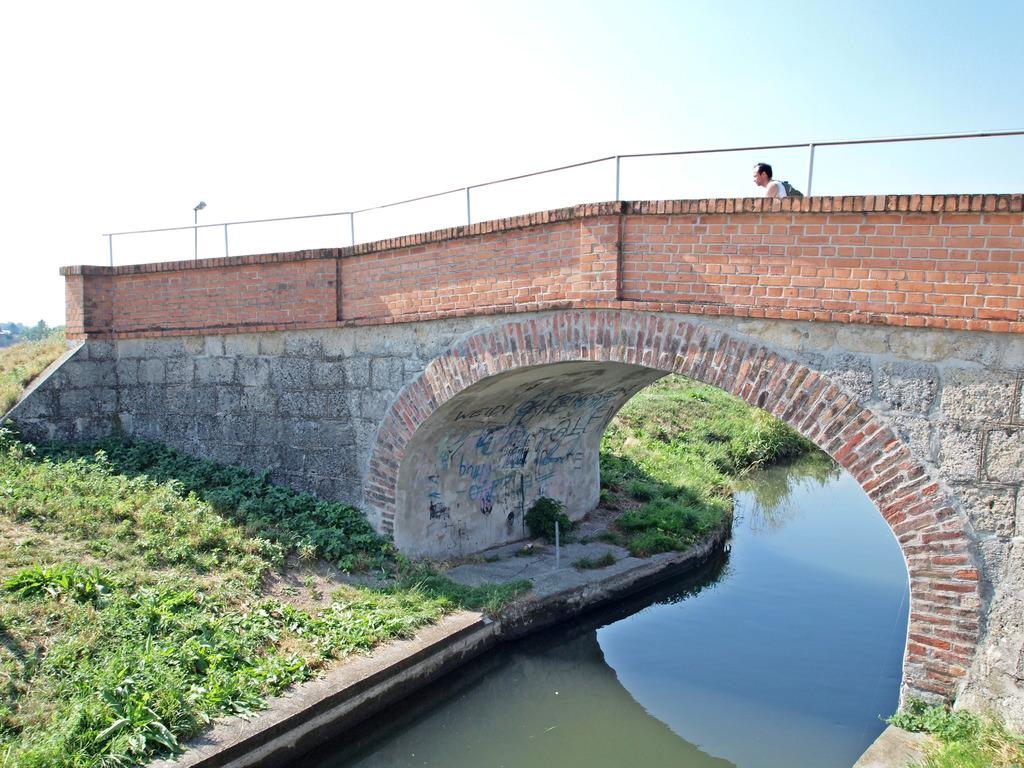What is the main structure in the foreground of the image? There is a bridge in the foreground of the image. What is happening under the bridge? Water is flowing under the bridge. What type of vegetation can be seen on the ground? There are plants and grass on the ground. What can be seen in the background of the image? The sky is visible in the background of the image. What is the price of the cemetery in the image? There is no cemetery present in the image, so it is not possible to determine its price. 